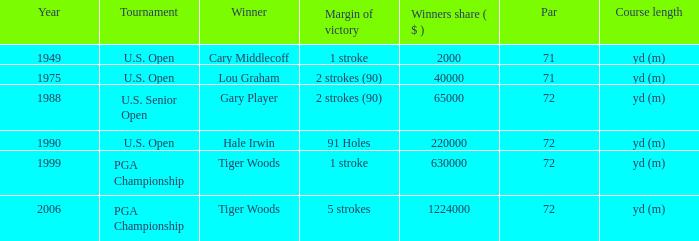Upon cary middlecoff's triumph, how many pars can be counted? 1.0. I'm looking to parse the entire table for insights. Could you assist me with that? {'header': ['Year', 'Tournament', 'Winner', 'Margin of victory', 'Winners share ( $ )', 'Par', 'Course length'], 'rows': [['1949', 'U.S. Open', 'Cary Middlecoff', '1 stroke', '2000', '71', 'yd (m)'], ['1975', 'U.S. Open', 'Lou Graham', '2 strokes (90)', '40000', '71', 'yd (m)'], ['1988', 'U.S. Senior Open', 'Gary Player', '2 strokes (90)', '65000', '72', 'yd (m)'], ['1990', 'U.S. Open', 'Hale Irwin', '91 Holes', '220000', '72', 'yd (m)'], ['1999', 'PGA Championship', 'Tiger Woods', '1 stroke', '630000', '72', 'yd (m)'], ['2006', 'PGA Championship', 'Tiger Woods', '5 strokes', '1224000', '72', 'yd (m)']]} 